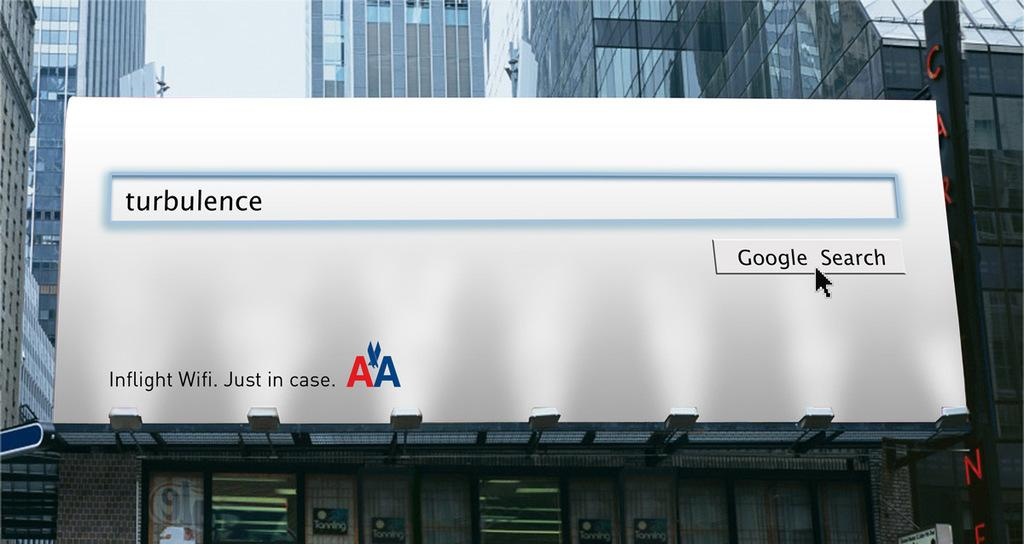<image>
Write a terse but informative summary of the picture. An American Airlines billboard that mimics a google search. 